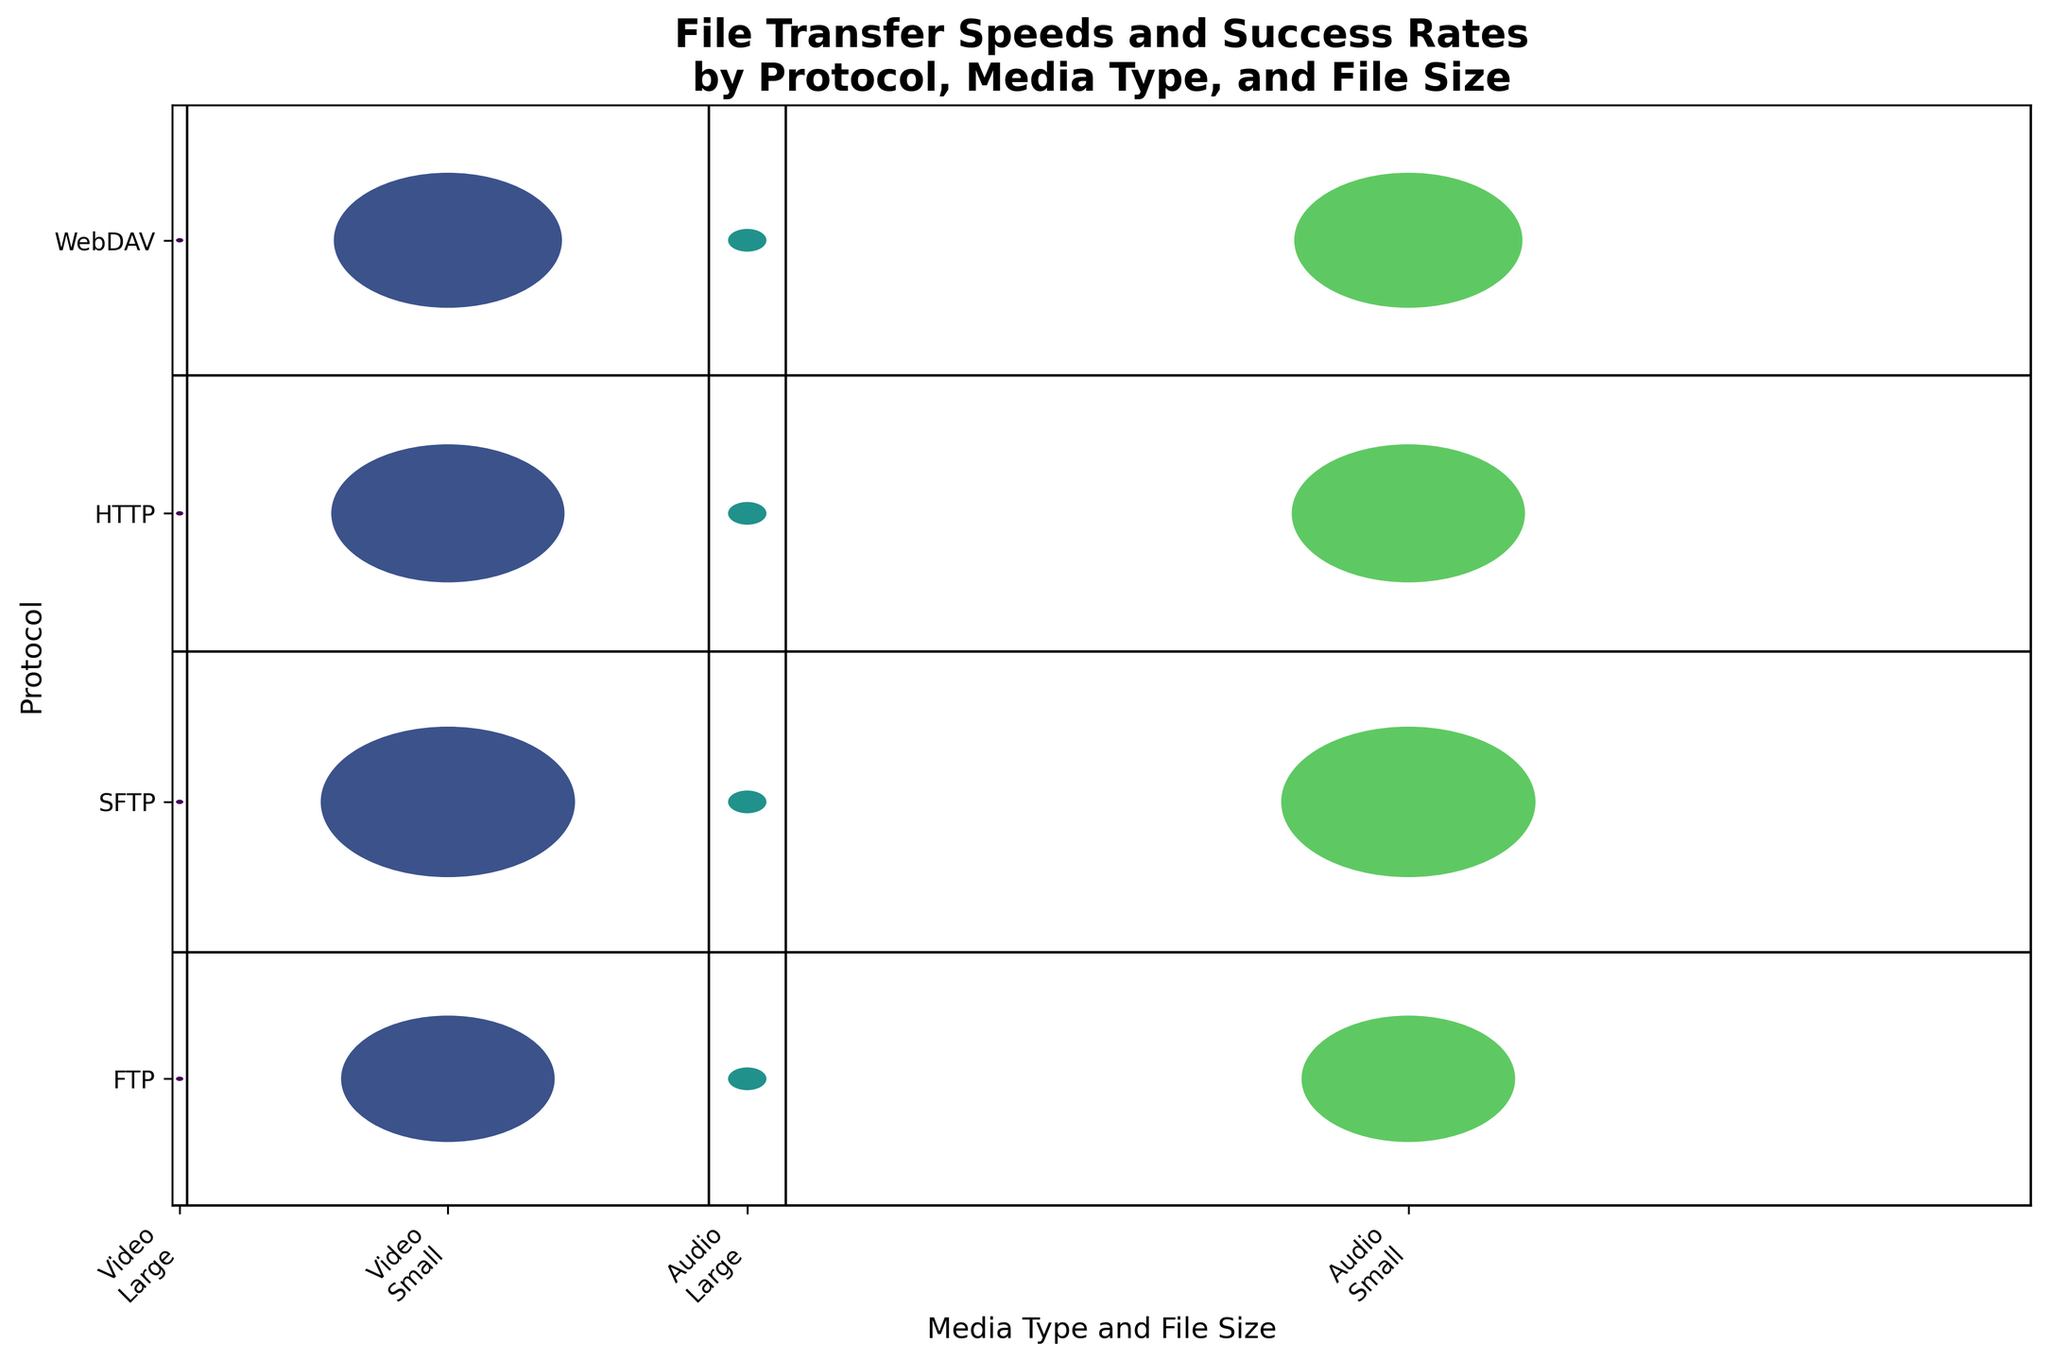What is the title of the figure? The title is typically displayed at the top of the plot. For this figure, the title given in the code is "File Transfer Speeds and Success Rates by Protocol, Media Type, and File Size."
Answer: File Transfer Speeds and Success Rates by Protocol, Media Type, and File Size Which protocol shows the highest success rate for large video files? Identify the section corresponding to each protocol and find the one with the highest success rate value for large video files. From the data, SFTP has the highest success rate of 92 for large video files.
Answer: SFTP How do the transfer speeds for small audio files compare across different protocols? Look at each protocol's segment for small audio files and compare the corresponding transfer speeds. FTP, SFTP, HTTP, and WebDAV have transfer speeds of 30, 25, 35, and 28 respectively. HTTP has the highest and SFTP has the lowest.
Answer: HTTP > FTP >= WebDAV > SFTP What is the average transfer speed for video files across all protocols? Sum the transfer speeds for video files (10 + 25 + 8 + 20 + 12 + 28 + 9 + 22) and divide by the number of data points (8). This results in (10 + 25 + 8 + 20 + 12 + 28 + 9 + 22) / 8 = 16.75 as the average transfer speed.
Answer: 16.75 Which protocol has the most uniform distribution of success rates across different media types and file sizes? Observe the size of the sections representing the success rates for each protocol. The protocol with the sections that appear the most uniform in height likely has the most consistent success rates. SFTP seems to have fairly uniform success rates across different categories.
Answer: SFTP What is the difference in success rates for small video files between FTP and HTTP? The success rate for small video files is provided in the data (95 for FTP and 96 for HTTP). The difference is calculated as 96 - 95.
Answer: 1 How does the success rate for large audio files using WebDAV compare with that of SFTP? Examine the height of the sections for large audio files for both protocols. The success rates are 92 for WebDAV and 95 for SFTP, so WebDAV's success rate is lower.
Answer: SFTP > WebDAV By looking at the figure, can you identify which media type generally has higher transfer speeds? Compare the widths representing transfer speeds for audio and video files. Audio files generally have wider sections indicating higher transfer speeds across most protocols.
Answer: Audio Are smaller file sizes more likely to have higher transfer speeds regardless of the protocol used? Compare the widths of the sections corresponding to smaller and larger file sizes within each protocol category. Smaller file sizes tend to have wider sections, indicating higher transfer speeds compared to larger file sizes within the same protocol.
Answer: Yes 